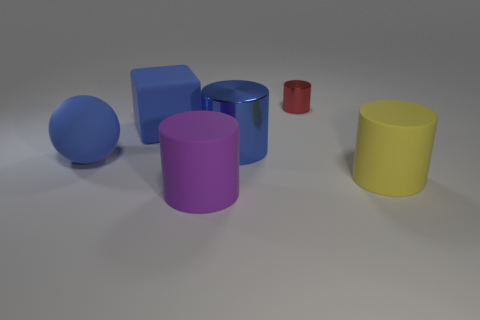There is a big thing that is in front of the big cylinder that is right of the red thing; how many rubber cylinders are to the left of it?
Provide a short and direct response. 0. How many gray objects are tiny things or big things?
Provide a succinct answer. 0. The big object on the right side of the tiny shiny object has what shape?
Give a very brief answer. Cylinder. What is the color of the sphere that is the same size as the purple thing?
Keep it short and to the point. Blue. Is the shape of the large blue metallic thing the same as the large blue rubber thing that is behind the large blue ball?
Your answer should be compact. No. There is a big cylinder that is behind the blue matte thing in front of the big cylinder that is behind the large ball; what is its material?
Your answer should be very brief. Metal. What number of small objects are cyan balls or rubber blocks?
Your answer should be compact. 0. What number of other objects are the same size as the purple matte thing?
Your answer should be very brief. 4. Do the large matte object that is in front of the yellow rubber cylinder and the tiny object have the same shape?
Make the answer very short. Yes. There is another small shiny object that is the same shape as the purple thing; what is its color?
Your answer should be compact. Red. 